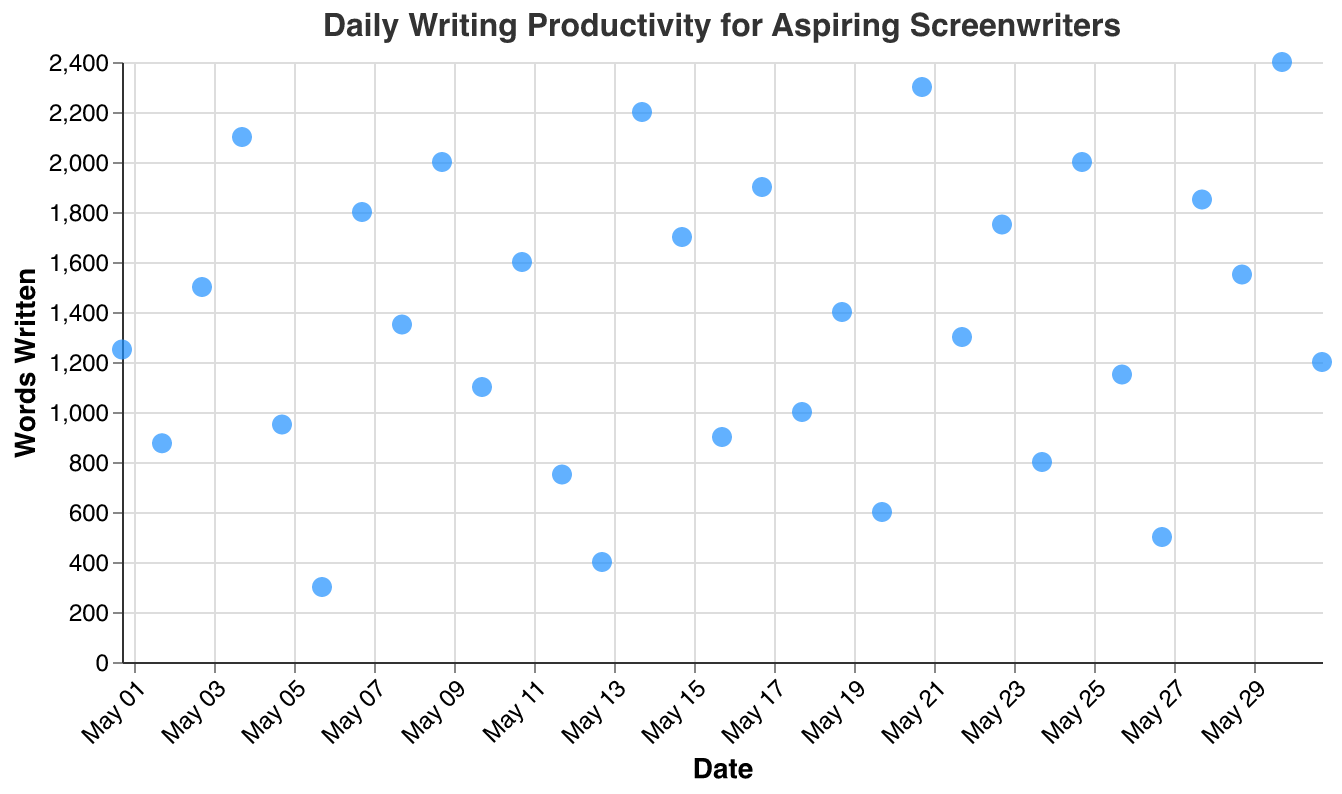what is the title of the plot? The title of the plot is usually placed at the top of the chart. In this figure, it says "Daily Writing Productivity for Aspiring Screenwriters".
Answer: Daily Writing Productivity for Aspiring Screenwriters What is the date range covered by the plot? The x-axis represents the dates, starting from "2023-05-01" and ending at "2023-05-31".
Answer: May 1, 2023, to May 31, 2023 How many points are shown in the plot? The plot shows one point for each day in the range from May 1 to May 31. Since May has 31 days, there are 31 points in the plot.
Answer: 31 What is the highest productivity day? By examining the points on the y-axis (Words Written), the highest point corresponds to 2400 words written on May 30.
Answer: May 30 Which day has the lowest productivity? The lowest point by looking at the y-axis is 300 words written on May 6.
Answer: May 6 How many days did the writer write more than 2000 words? By inspecting points above the 2000 words mark on the y-axis, the writer wrote more than 2000 words on May 21, May 14, and May 30.
Answer: 3 days What is the average number of words written per day? To find the average, sum all values (1250 + 875 + 1500 + 2100 + 950 + 300 + 1800 + 1350 + 2000 + 1100 + 1600 + 750 + 400 + 2200 + 1700 + 900 + 1900 + 1000 + 1400 + 600 + 2300 + 1300 + 1750 + 800 + 2000 + 1150 + 500 + 1850 + 1550 + 2400 + 1200 = 38925), then divide by 31. The average is 38925/31 ≈ 1255 words/day.
Answer: 1255 words/day Which days had the same productivity of 2000 words? By inspecting the y-axis, the writer wrote exactly 2000 words on May 9 and May 25.
Answer: May 9, May 25 Did the writer's productivity increase, decrease, or stay constant towards the end of the month? Observing the trend of the last few points, points (May 28: 1850, May 29: 1550, May 30: 2400, May 31: 1200), the productivity was mixed but had a notable peak on May 30. It’s both increasing and decreasing, depending on the day.
Answer: Mixed On what day did the writer write exactly 1200 words? By referring to the y-axis, the writer wrote 1200 words on May 31.
Answer: May 31 